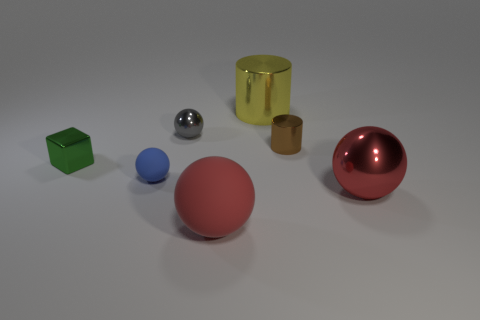Are there any small shiny objects of the same color as the big metallic ball?
Give a very brief answer. No. What number of things are tiny things that are to the left of the blue ball or large blue blocks?
Provide a succinct answer. 1. Is the small cylinder made of the same material as the big ball left of the small metallic cylinder?
Provide a succinct answer. No. The metal sphere that is the same color as the big matte ball is what size?
Make the answer very short. Large. Is there a tiny blue cylinder that has the same material as the tiny brown cylinder?
Provide a succinct answer. No. How many objects are either large things that are in front of the tiny blue object or small gray metal things that are behind the small shiny cylinder?
Offer a terse response. 3. There is a big red matte object; does it have the same shape as the metallic thing that is behind the tiny gray thing?
Provide a short and direct response. No. How many other objects are there of the same shape as the tiny blue object?
Your answer should be compact. 3. How many objects are small blue rubber objects or green shiny cylinders?
Offer a very short reply. 1. Is the big matte sphere the same color as the big cylinder?
Keep it short and to the point. No. 